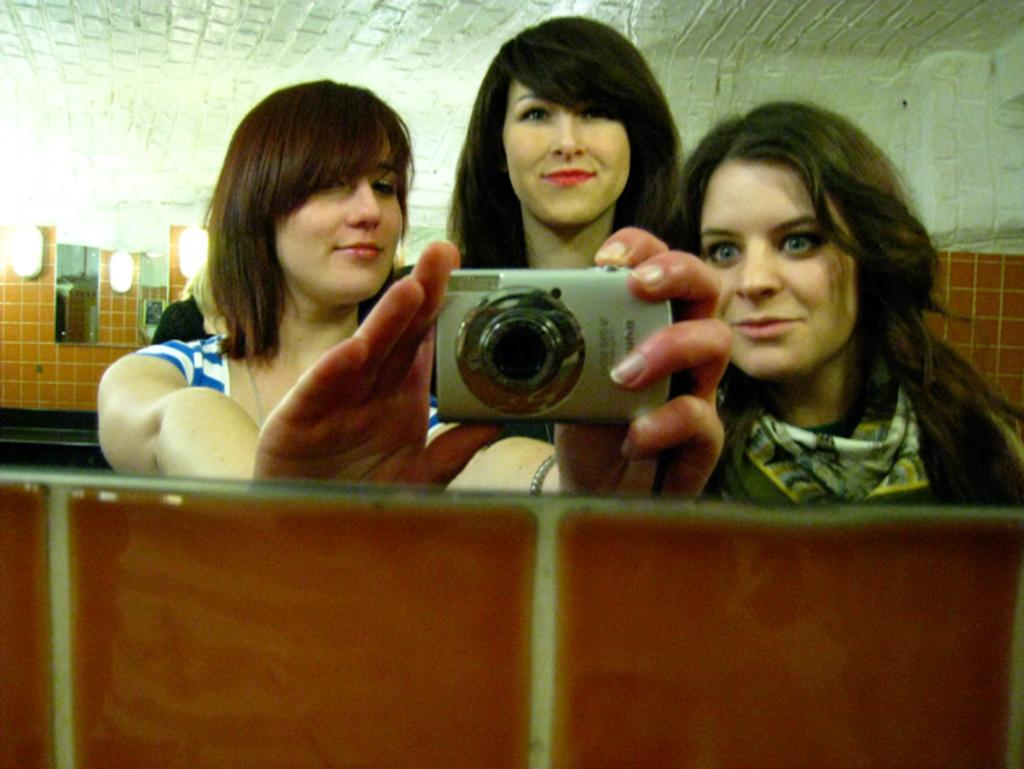How many women are in the image? There are three women in the image. What are the women doing in the image? The women are smiling, and one of them is holding a camera. What can be seen in the background of the image? There is a wall and lights in the background of the image. What type of bushes can be seen in the image? There are no bushes present in the image. Can you tell me what type of judge is in the image? There is no judge present in the image. 